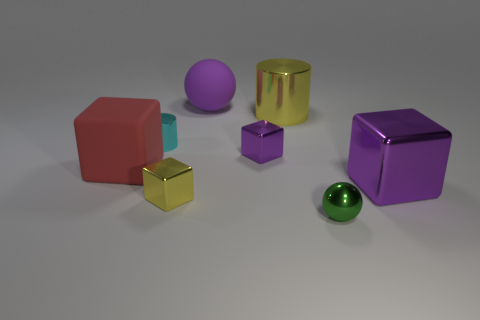There is a small metal thing that is the same color as the large metallic cylinder; what shape is it?
Keep it short and to the point. Cube. What is the size of the other object that is the same shape as the small green shiny object?
Provide a succinct answer. Large. How many other cubes have the same color as the large shiny cube?
Give a very brief answer. 1. Does the purple shiny thing in front of the big red block have the same size as the cube that is behind the big red rubber cube?
Give a very brief answer. No. There is a small block that is the same color as the big cylinder; what is its material?
Give a very brief answer. Metal. What is the color of the large cube to the left of the tiny purple cube?
Provide a short and direct response. Red. Does the large sphere have the same color as the large shiny cube?
Keep it short and to the point. Yes. What number of big purple metal blocks are to the right of the small metal block that is behind the rubber thing in front of the small cylinder?
Offer a terse response. 1. How big is the yellow cylinder?
Keep it short and to the point. Large. What material is the green sphere that is the same size as the cyan cylinder?
Your answer should be very brief. Metal. 